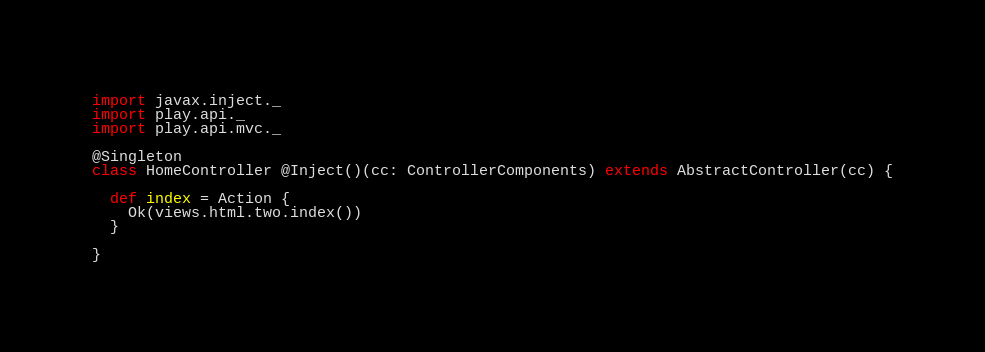Convert code to text. <code><loc_0><loc_0><loc_500><loc_500><_Scala_>import javax.inject._
import play.api._
import play.api.mvc._

@Singleton
class HomeController @Inject()(cc: ControllerComponents) extends AbstractController(cc) {

  def index = Action {
    Ok(views.html.two.index())
  }

}
</code> 